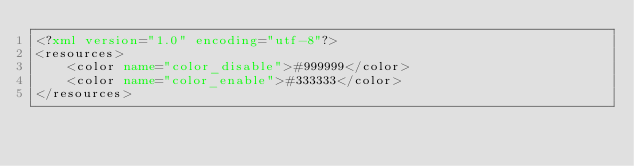<code> <loc_0><loc_0><loc_500><loc_500><_XML_><?xml version="1.0" encoding="utf-8"?>
<resources>
    <color name="color_disable">#999999</color>
    <color name="color_enable">#333333</color>
</resources></code> 